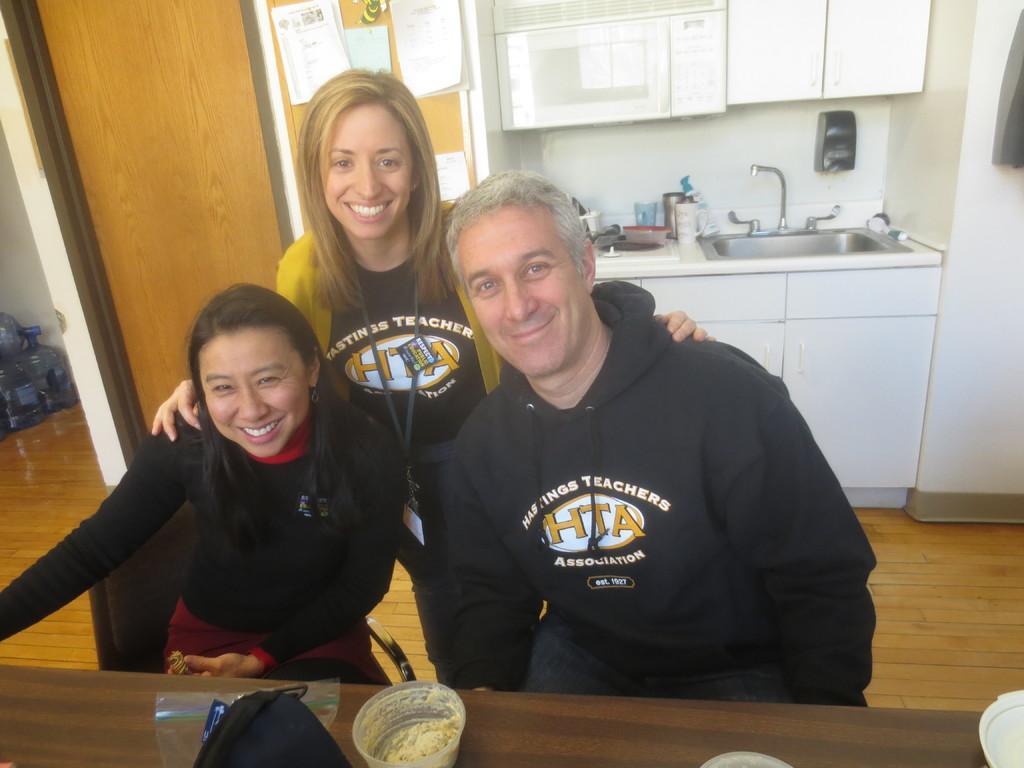Can you describe this image briefly? This is image of inside view of a house and there is a three visible. And left side a woman wearing a black color skirt sit on the chair she is smiling ,on the middle a woman wearing a yellow color top she is smiling. On the back side of her there is a wall and there are papers kept and right side i can see a sink and left side i can see a bottles kept on the floor , in front of them there is a table ,on the table there are some objects kept on the table 